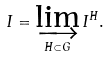<formula> <loc_0><loc_0><loc_500><loc_500>I = \varinjlim _ { H \subset G } I ^ { H } .</formula> 